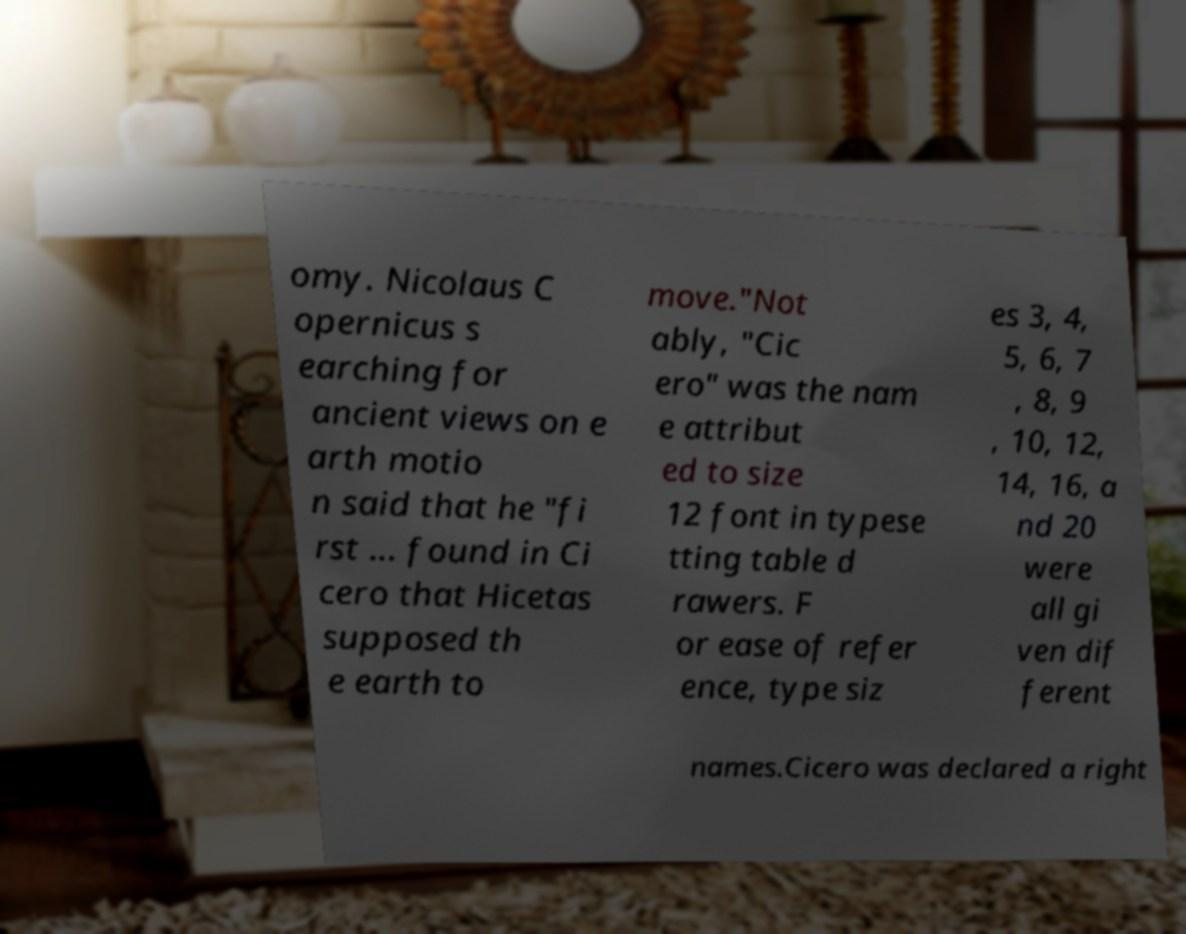There's text embedded in this image that I need extracted. Can you transcribe it verbatim? omy. Nicolaus C opernicus s earching for ancient views on e arth motio n said that he "fi rst ... found in Ci cero that Hicetas supposed th e earth to move."Not ably, "Cic ero" was the nam e attribut ed to size 12 font in typese tting table d rawers. F or ease of refer ence, type siz es 3, 4, 5, 6, 7 , 8, 9 , 10, 12, 14, 16, a nd 20 were all gi ven dif ferent names.Cicero was declared a right 